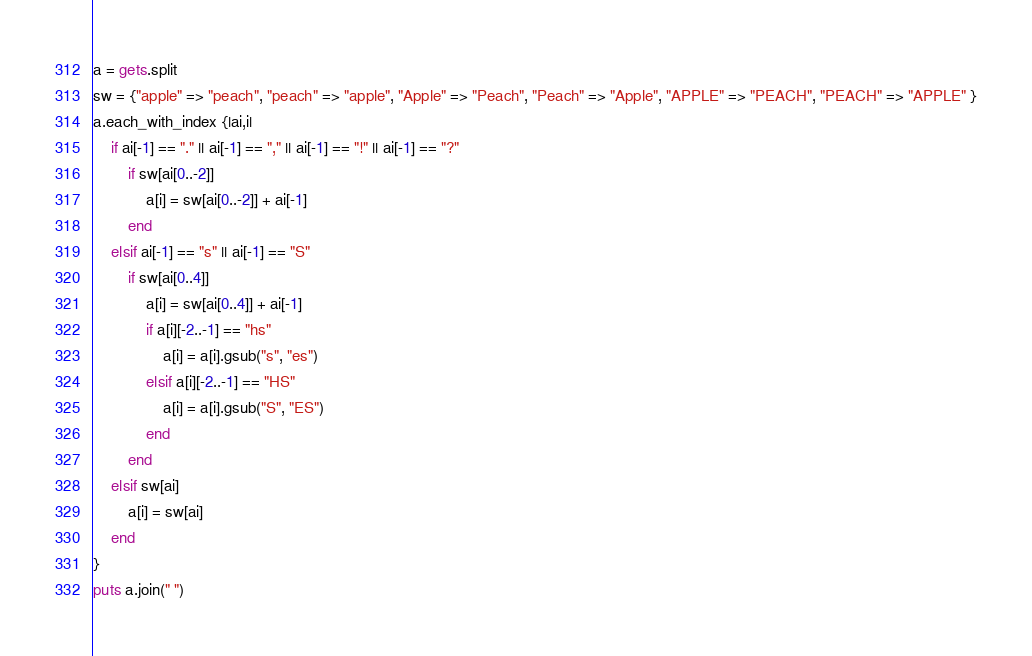<code> <loc_0><loc_0><loc_500><loc_500><_Ruby_>a = gets.split
sw = {"apple" => "peach", "peach" => "apple", "Apple" => "Peach", "Peach" => "Apple", "APPLE" => "PEACH", "PEACH" => "APPLE" }
a.each_with_index {|ai,i|
	if ai[-1] == "." || ai[-1] == "," || ai[-1] == "!" || ai[-1] == "?" 
		if sw[ai[0..-2]]
			a[i] = sw[ai[0..-2]] + ai[-1]
		end
	elsif ai[-1] == "s" || ai[-1] == "S"
		if sw[ai[0..4]]
			a[i] = sw[ai[0..4]] + ai[-1]
			if a[i][-2..-1] == "hs"
				a[i] = a[i].gsub("s", "es")
			elsif a[i][-2..-1] == "HS"
				a[i] = a[i].gsub("S", "ES")
			end
		end
	elsif sw[ai]
		a[i] = sw[ai]
	end
}
puts a.join(" ")</code> 